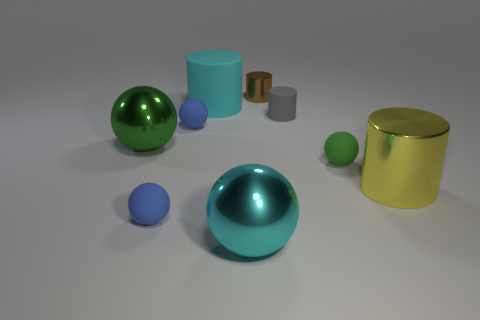Which object appears to be the largest in the image? The yellow metal cylinder appears to be the largest object in the image, both in terms of height and volume. 